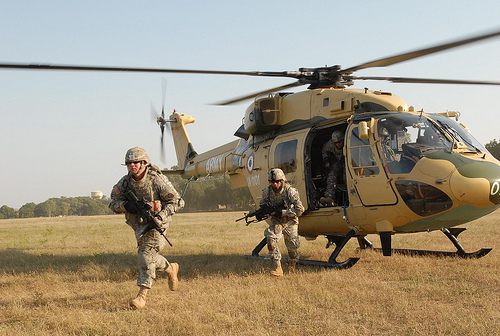<image>
Is there a gun under the soldier? No. The gun is not positioned under the soldier. The vertical relationship between these objects is different. Is there a blade above the man? Yes. The blade is positioned above the man in the vertical space, higher up in the scene. 